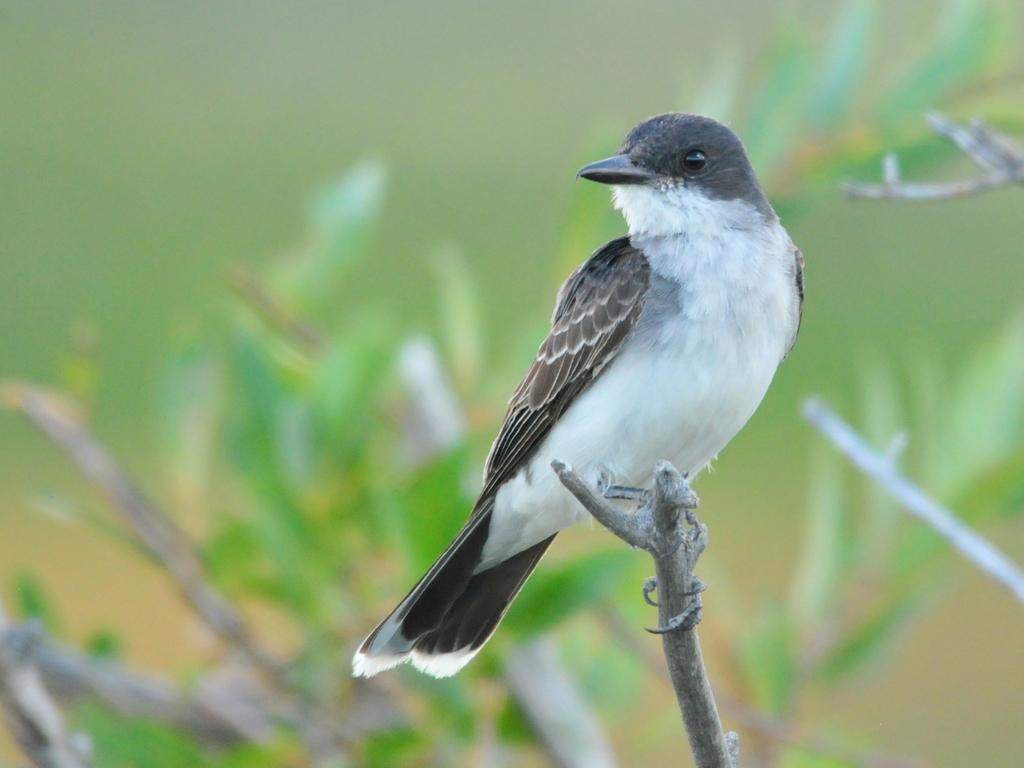In one or two sentences, can you explain what this image depicts? In this image we can see there is a bird on the stick and blur background. 